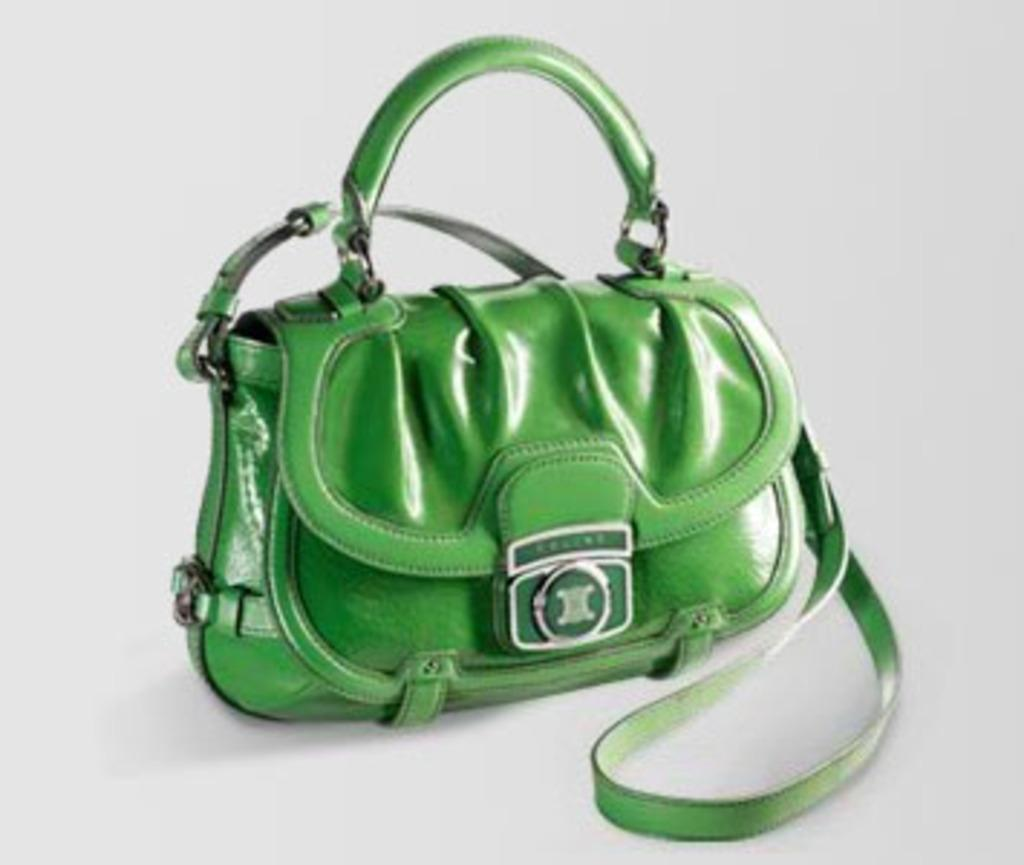What object is present in the image that can be used for carrying items? There is a bag in the image that can be used for carrying items. What is the color of the bag in the image? The bag is green in color. How can the bag be carried in the image? The bag has a handle and one strap for carrying. What type of nose can be seen on the bag in the image? There is no nose present on the bag in the image, as it is an inanimate object. 